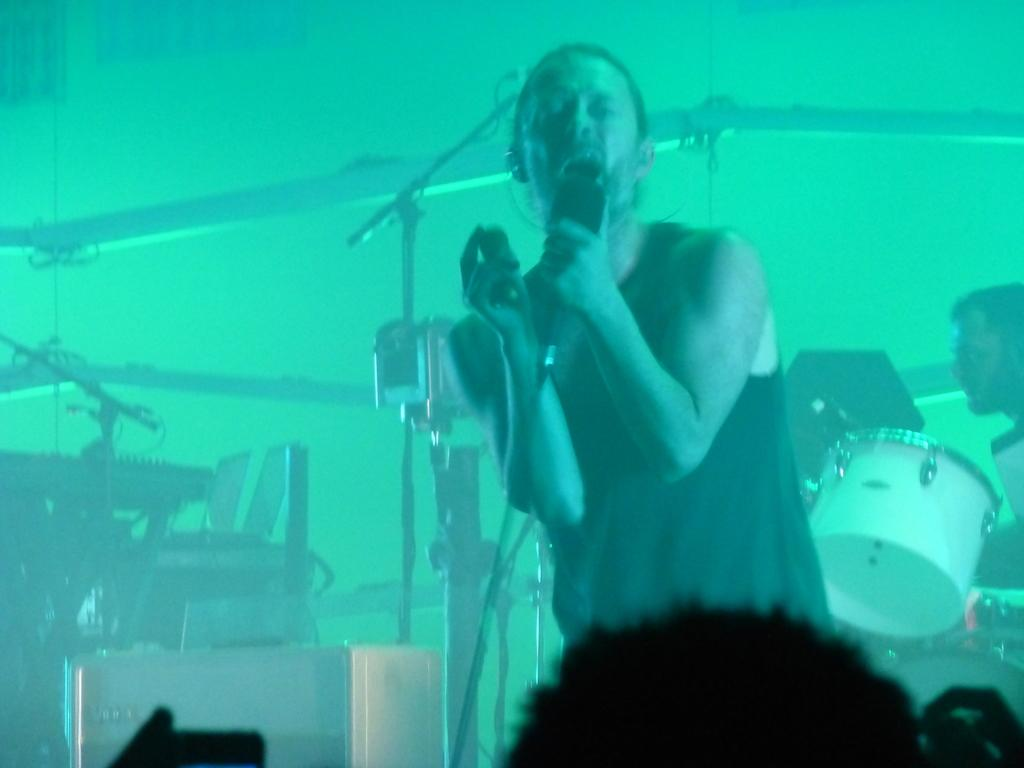Who is the main subject in the image? There is a man in the image. What is the man doing in the image? The man is standing and holding a mic in his hands. What can be seen in the background of the image? There are musical instruments and persons in the background of the image. What type of soap is being used by the man in the image? There is no soap present in the image; the man is holding a mic and standing. 